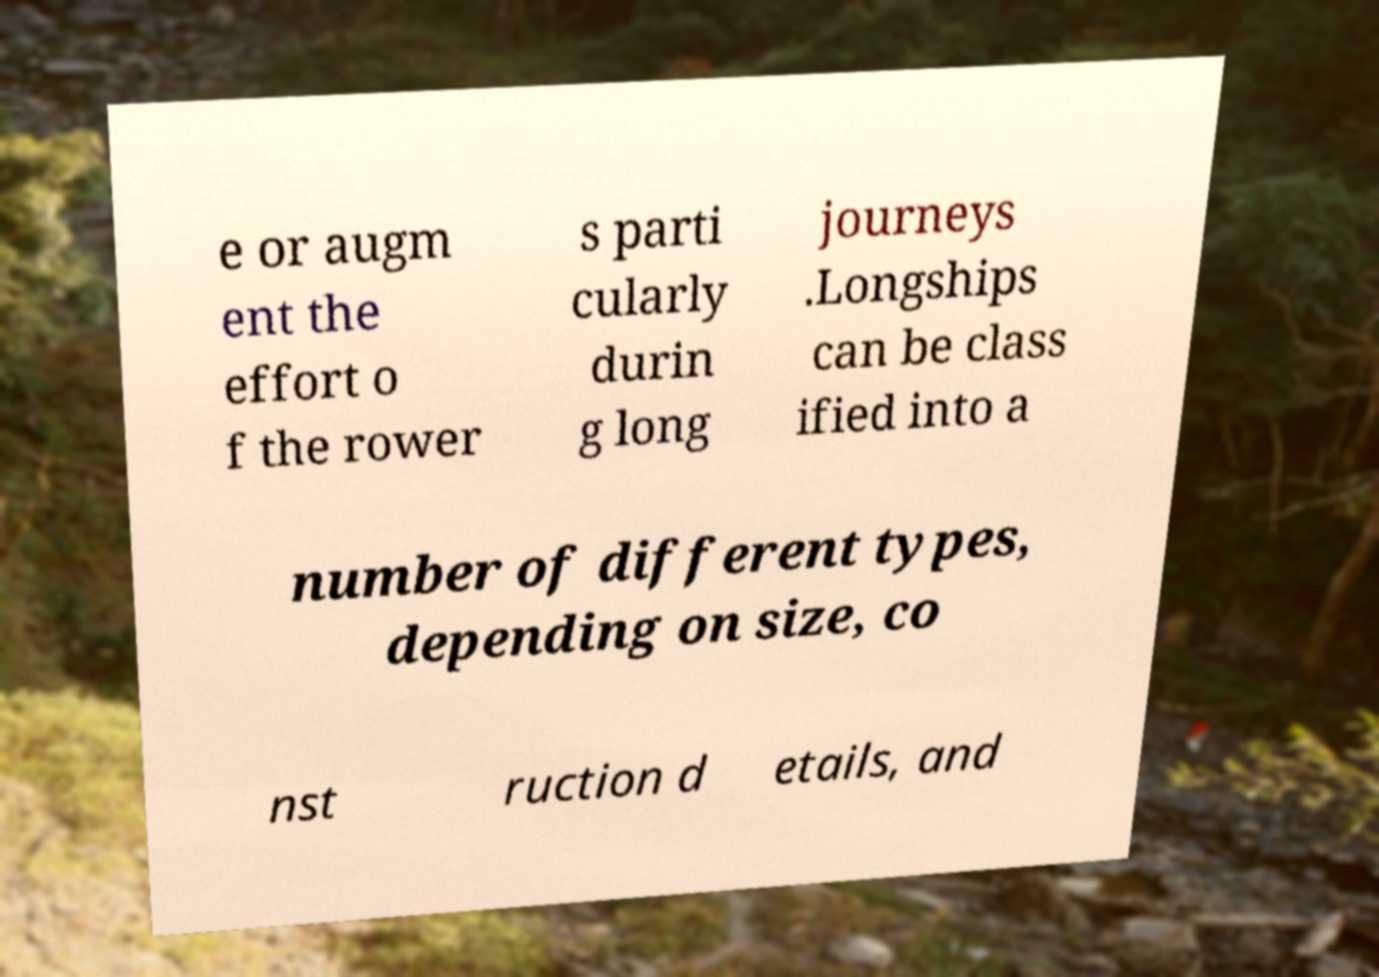Could you assist in decoding the text presented in this image and type it out clearly? e or augm ent the effort o f the rower s parti cularly durin g long journeys .Longships can be class ified into a number of different types, depending on size, co nst ruction d etails, and 